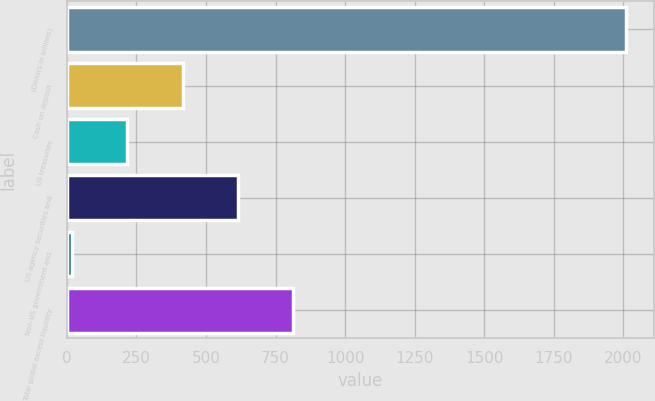<chart> <loc_0><loc_0><loc_500><loc_500><bar_chart><fcel>(Dollars in billions)<fcel>Cash on deposit<fcel>US treasuries<fcel>US agency securities and<fcel>Non-US government and<fcel>Total global excess liquidity<nl><fcel>2010<fcel>415.6<fcel>216.3<fcel>614.9<fcel>17<fcel>814.2<nl></chart> 